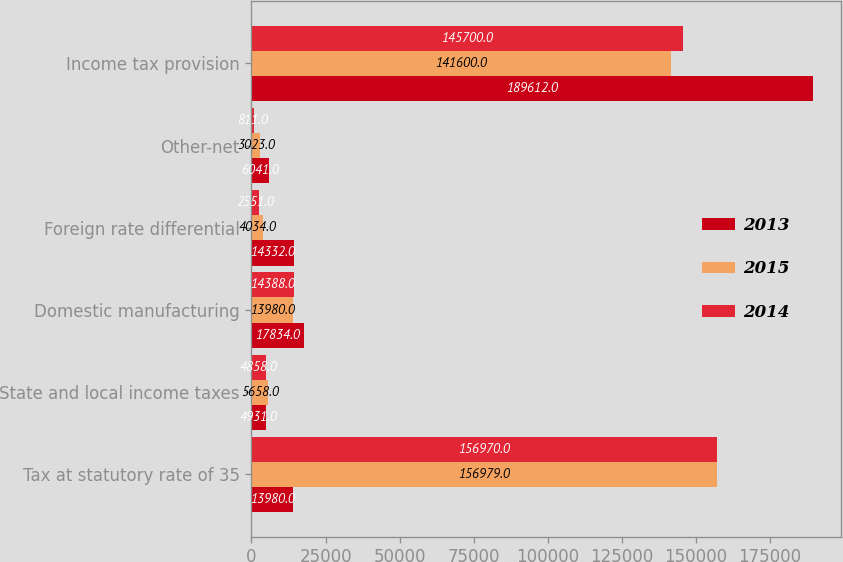Convert chart. <chart><loc_0><loc_0><loc_500><loc_500><stacked_bar_chart><ecel><fcel>Tax at statutory rate of 35<fcel>State and local income taxes<fcel>Domestic manufacturing<fcel>Foreign rate differential<fcel>Other-net<fcel>Income tax provision<nl><fcel>2013<fcel>13980<fcel>4931<fcel>17834<fcel>14332<fcel>6041<fcel>189612<nl><fcel>2015<fcel>156979<fcel>5658<fcel>13980<fcel>4034<fcel>3023<fcel>141600<nl><fcel>2014<fcel>156970<fcel>4858<fcel>14388<fcel>2551<fcel>811<fcel>145700<nl></chart> 